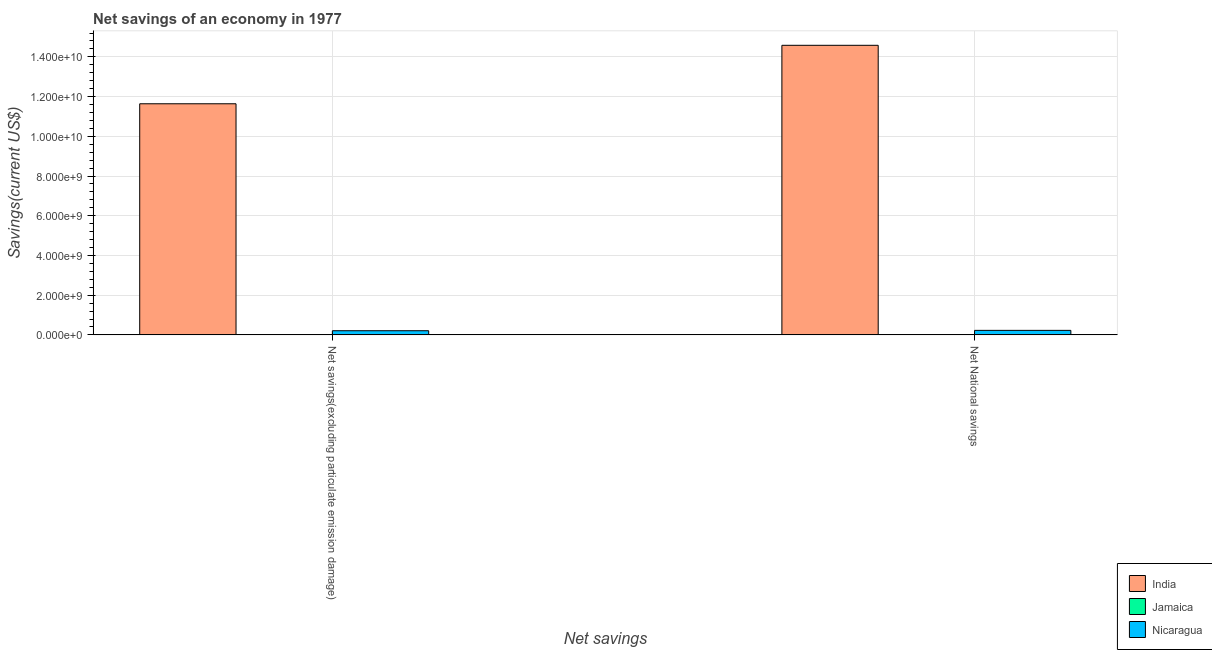Are the number of bars per tick equal to the number of legend labels?
Your answer should be compact. No. How many bars are there on the 2nd tick from the right?
Your answer should be very brief. 2. What is the label of the 1st group of bars from the left?
Ensure brevity in your answer.  Net savings(excluding particulate emission damage). What is the net national savings in Nicaragua?
Give a very brief answer. 2.28e+08. Across all countries, what is the maximum net savings(excluding particulate emission damage)?
Your answer should be compact. 1.16e+1. In which country was the net national savings maximum?
Your answer should be very brief. India. What is the total net savings(excluding particulate emission damage) in the graph?
Keep it short and to the point. 1.18e+1. What is the difference between the net national savings in Nicaragua and that in India?
Give a very brief answer. -1.44e+1. What is the difference between the net savings(excluding particulate emission damage) in Nicaragua and the net national savings in Jamaica?
Your answer should be very brief. 2.10e+08. What is the average net savings(excluding particulate emission damage) per country?
Offer a very short reply. 3.95e+09. What is the difference between the net national savings and net savings(excluding particulate emission damage) in Nicaragua?
Your answer should be very brief. 1.80e+07. What is the ratio of the net savings(excluding particulate emission damage) in Nicaragua to that in India?
Keep it short and to the point. 0.02. Is the net savings(excluding particulate emission damage) in India less than that in Nicaragua?
Keep it short and to the point. No. How many bars are there?
Offer a terse response. 4. How many countries are there in the graph?
Ensure brevity in your answer.  3. What is the difference between two consecutive major ticks on the Y-axis?
Provide a short and direct response. 2.00e+09. How many legend labels are there?
Provide a short and direct response. 3. How are the legend labels stacked?
Your response must be concise. Vertical. What is the title of the graph?
Provide a short and direct response. Net savings of an economy in 1977. What is the label or title of the X-axis?
Make the answer very short. Net savings. What is the label or title of the Y-axis?
Keep it short and to the point. Savings(current US$). What is the Savings(current US$) in India in Net savings(excluding particulate emission damage)?
Offer a terse response. 1.16e+1. What is the Savings(current US$) in Nicaragua in Net savings(excluding particulate emission damage)?
Make the answer very short. 2.10e+08. What is the Savings(current US$) of India in Net National savings?
Your answer should be very brief. 1.46e+1. What is the Savings(current US$) of Jamaica in Net National savings?
Offer a very short reply. 0. What is the Savings(current US$) of Nicaragua in Net National savings?
Make the answer very short. 2.28e+08. Across all Net savings, what is the maximum Savings(current US$) of India?
Provide a short and direct response. 1.46e+1. Across all Net savings, what is the maximum Savings(current US$) in Nicaragua?
Ensure brevity in your answer.  2.28e+08. Across all Net savings, what is the minimum Savings(current US$) in India?
Your answer should be very brief. 1.16e+1. Across all Net savings, what is the minimum Savings(current US$) in Nicaragua?
Provide a short and direct response. 2.10e+08. What is the total Savings(current US$) of India in the graph?
Your response must be concise. 2.62e+1. What is the total Savings(current US$) of Jamaica in the graph?
Your answer should be very brief. 0. What is the total Savings(current US$) in Nicaragua in the graph?
Offer a very short reply. 4.37e+08. What is the difference between the Savings(current US$) in India in Net savings(excluding particulate emission damage) and that in Net National savings?
Give a very brief answer. -2.94e+09. What is the difference between the Savings(current US$) in Nicaragua in Net savings(excluding particulate emission damage) and that in Net National savings?
Offer a very short reply. -1.80e+07. What is the difference between the Savings(current US$) in India in Net savings(excluding particulate emission damage) and the Savings(current US$) in Nicaragua in Net National savings?
Ensure brevity in your answer.  1.14e+1. What is the average Savings(current US$) of India per Net savings?
Offer a very short reply. 1.31e+1. What is the average Savings(current US$) in Nicaragua per Net savings?
Keep it short and to the point. 2.19e+08. What is the difference between the Savings(current US$) of India and Savings(current US$) of Nicaragua in Net savings(excluding particulate emission damage)?
Your answer should be very brief. 1.14e+1. What is the difference between the Savings(current US$) in India and Savings(current US$) in Nicaragua in Net National savings?
Provide a short and direct response. 1.44e+1. What is the ratio of the Savings(current US$) of India in Net savings(excluding particulate emission damage) to that in Net National savings?
Make the answer very short. 0.8. What is the ratio of the Savings(current US$) of Nicaragua in Net savings(excluding particulate emission damage) to that in Net National savings?
Your answer should be compact. 0.92. What is the difference between the highest and the second highest Savings(current US$) of India?
Keep it short and to the point. 2.94e+09. What is the difference between the highest and the second highest Savings(current US$) of Nicaragua?
Your answer should be very brief. 1.80e+07. What is the difference between the highest and the lowest Savings(current US$) of India?
Give a very brief answer. 2.94e+09. What is the difference between the highest and the lowest Savings(current US$) of Nicaragua?
Ensure brevity in your answer.  1.80e+07. 